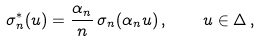<formula> <loc_0><loc_0><loc_500><loc_500>\sigma _ { n } ^ { * } ( u ) = \frac { \alpha _ { n } } { n } \, \sigma _ { n } ( \alpha _ { n } u ) \, , \quad u \in \Delta \, ,</formula> 